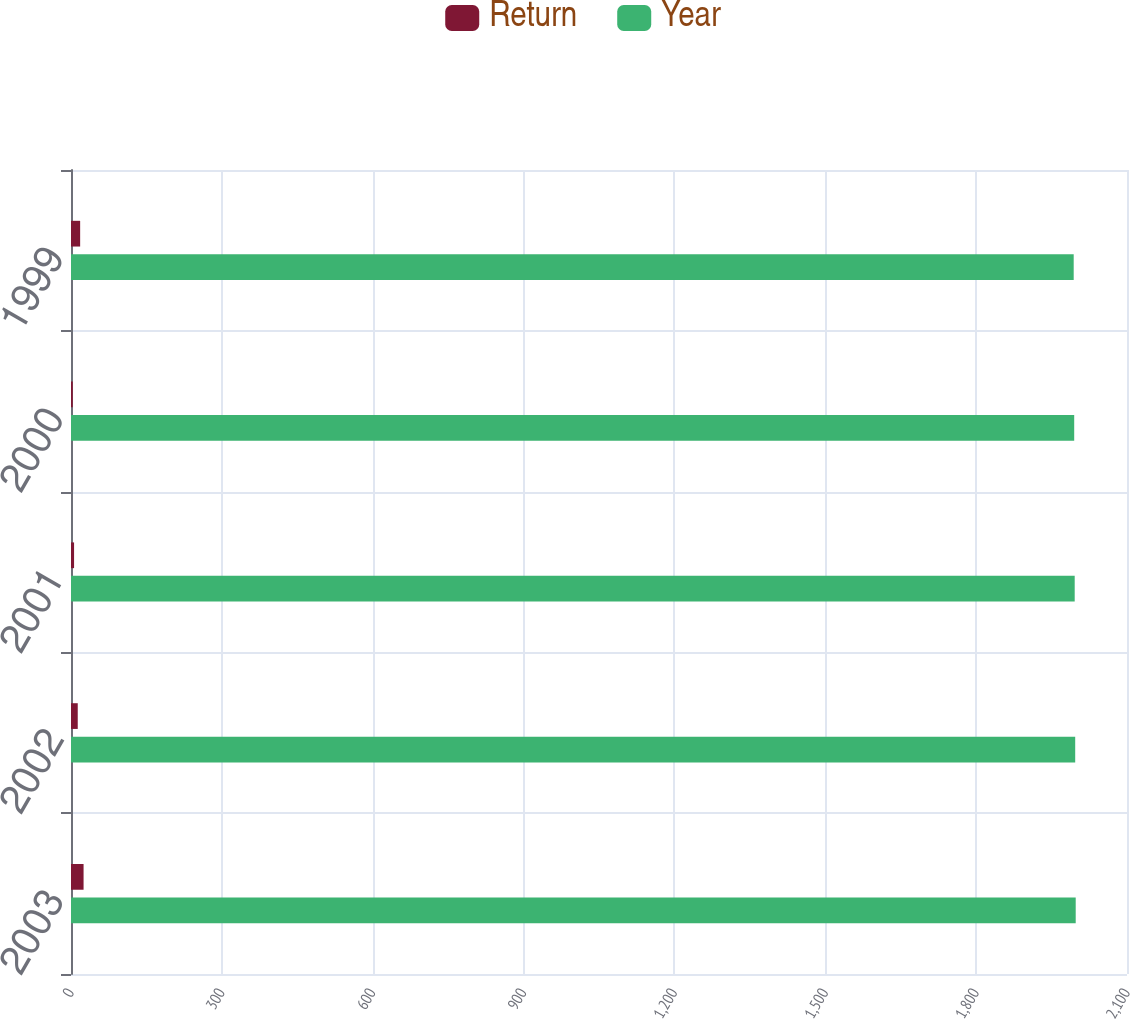Convert chart. <chart><loc_0><loc_0><loc_500><loc_500><stacked_bar_chart><ecel><fcel>2003<fcel>2002<fcel>2001<fcel>2000<fcel>1999<nl><fcel>Return<fcel>25<fcel>13.4<fcel>6.1<fcel>3.5<fcel>18.2<nl><fcel>Year<fcel>1998<fcel>1997<fcel>1996<fcel>1995<fcel>1994<nl></chart> 